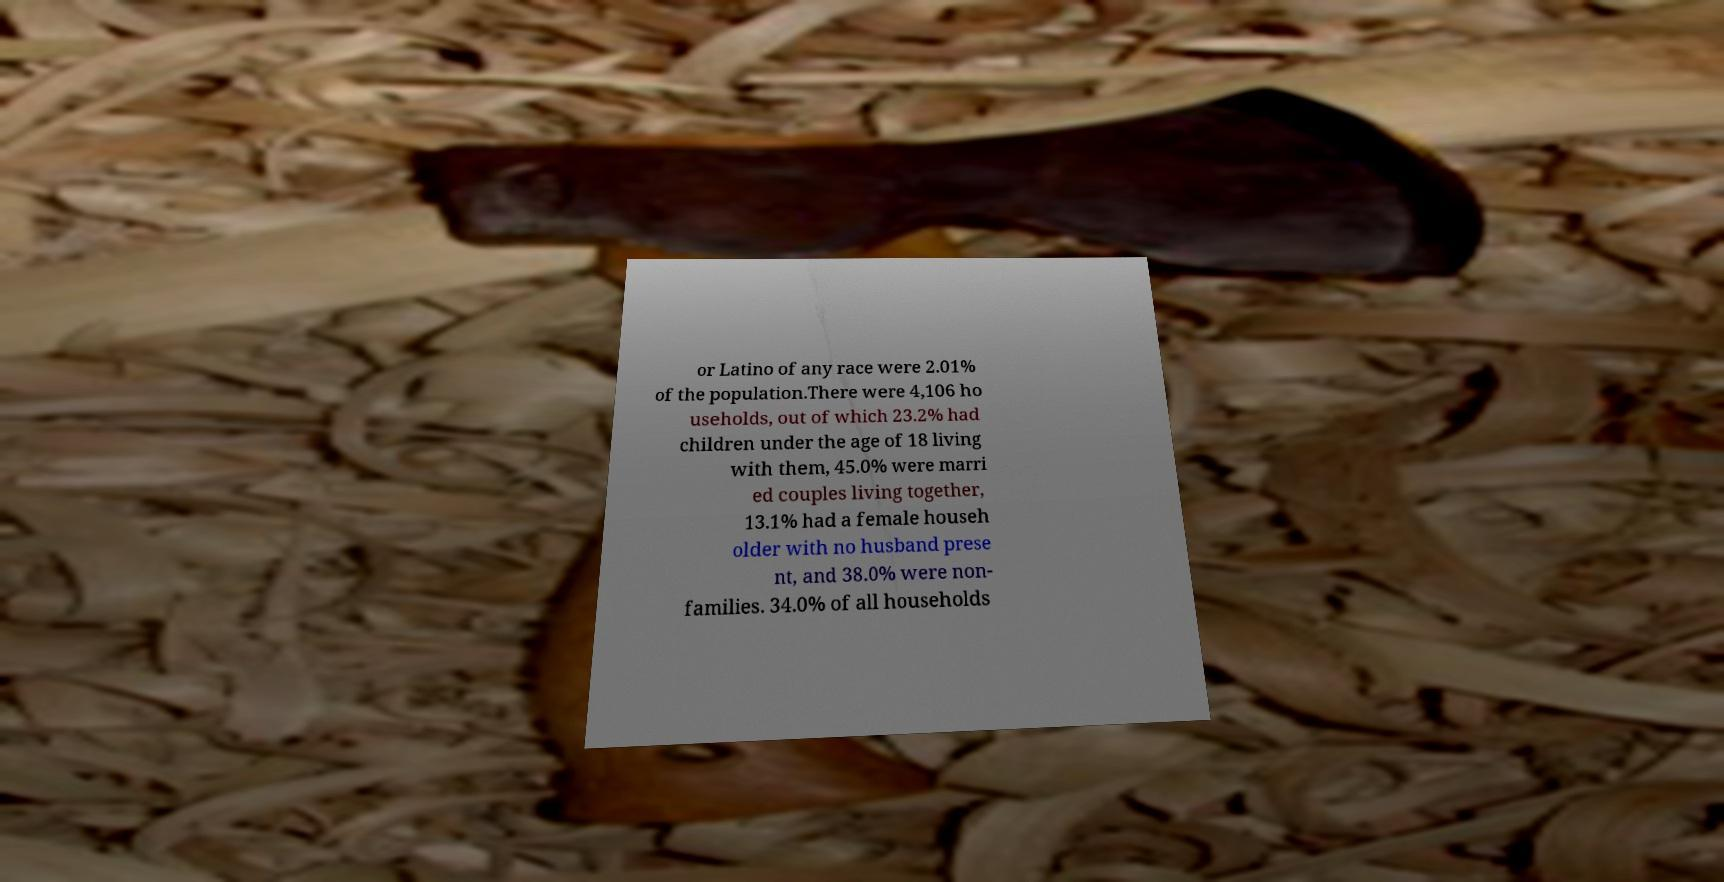What messages or text are displayed in this image? I need them in a readable, typed format. or Latino of any race were 2.01% of the population.There were 4,106 ho useholds, out of which 23.2% had children under the age of 18 living with them, 45.0% were marri ed couples living together, 13.1% had a female househ older with no husband prese nt, and 38.0% were non- families. 34.0% of all households 